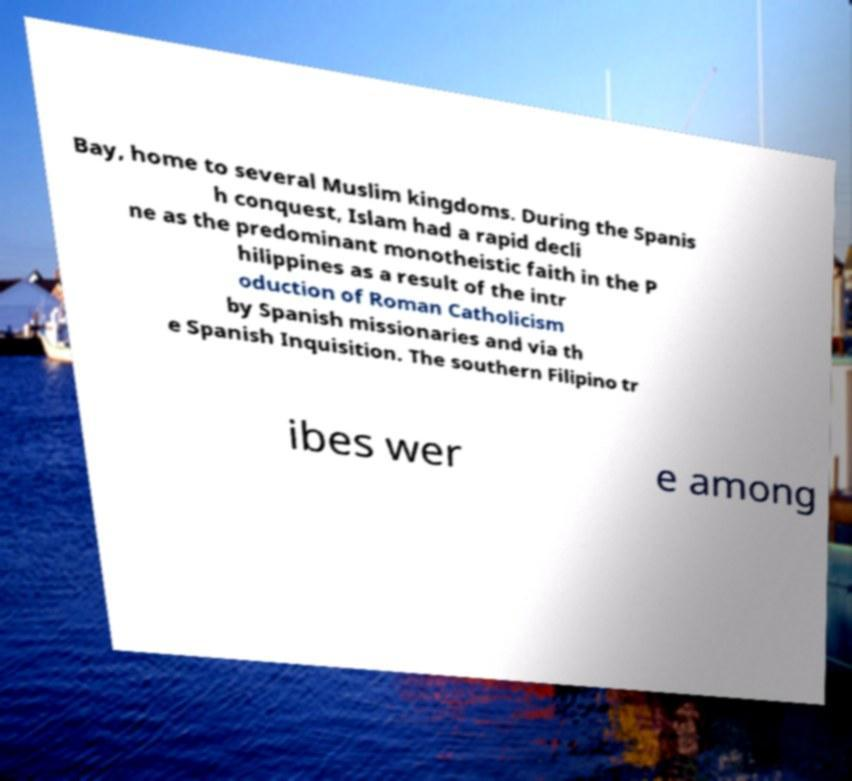For documentation purposes, I need the text within this image transcribed. Could you provide that? Bay, home to several Muslim kingdoms. During the Spanis h conquest, Islam had a rapid decli ne as the predominant monotheistic faith in the P hilippines as a result of the intr oduction of Roman Catholicism by Spanish missionaries and via th e Spanish Inquisition. The southern Filipino tr ibes wer e among 